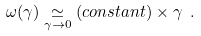Convert formula to latex. <formula><loc_0><loc_0><loc_500><loc_500>\omega ( \gamma ) \underset { \gamma \rightarrow 0 } { \simeq } ( c o n s t a n t ) \times \gamma \ .</formula> 